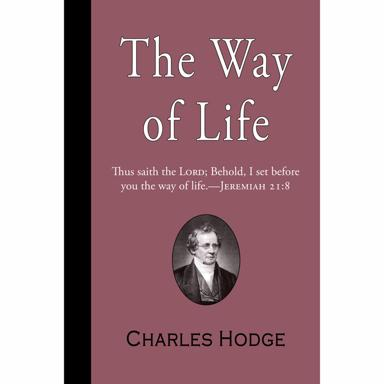What is the quote on the book cover? The quote on the book cover reads, "The Way of Life Thus saith the LORD Behold, I set before you the way of life. JEREMIAH 21 8." This inscription, alongside a portrait of Charles Hodge, adds a profound essence to the cover, inviting readers into the theological insights contained within. 